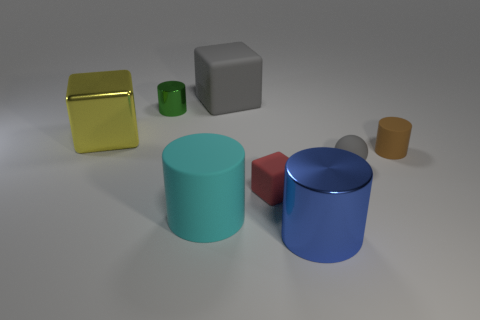Subtract all big blue metallic cylinders. How many cylinders are left? 3 Subtract all red cylinders. Subtract all green balls. How many cylinders are left? 4 Add 1 rubber cubes. How many objects exist? 9 Subtract all balls. How many objects are left? 7 Add 7 big cylinders. How many big cylinders exist? 9 Subtract 1 brown cylinders. How many objects are left? 7 Subtract all tiny yellow rubber balls. Subtract all yellow metal blocks. How many objects are left? 7 Add 5 large metallic blocks. How many large metallic blocks are left? 6 